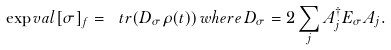Convert formula to latex. <formula><loc_0><loc_0><loc_500><loc_500>\exp v a l [ \sigma ] _ { f } = \ t r ( D _ { \sigma } \rho ( t ) ) \, w h e r e \, D _ { \sigma } = 2 \sum _ { j } A _ { j } ^ { \dagger } E _ { \sigma } A _ { j } .</formula> 